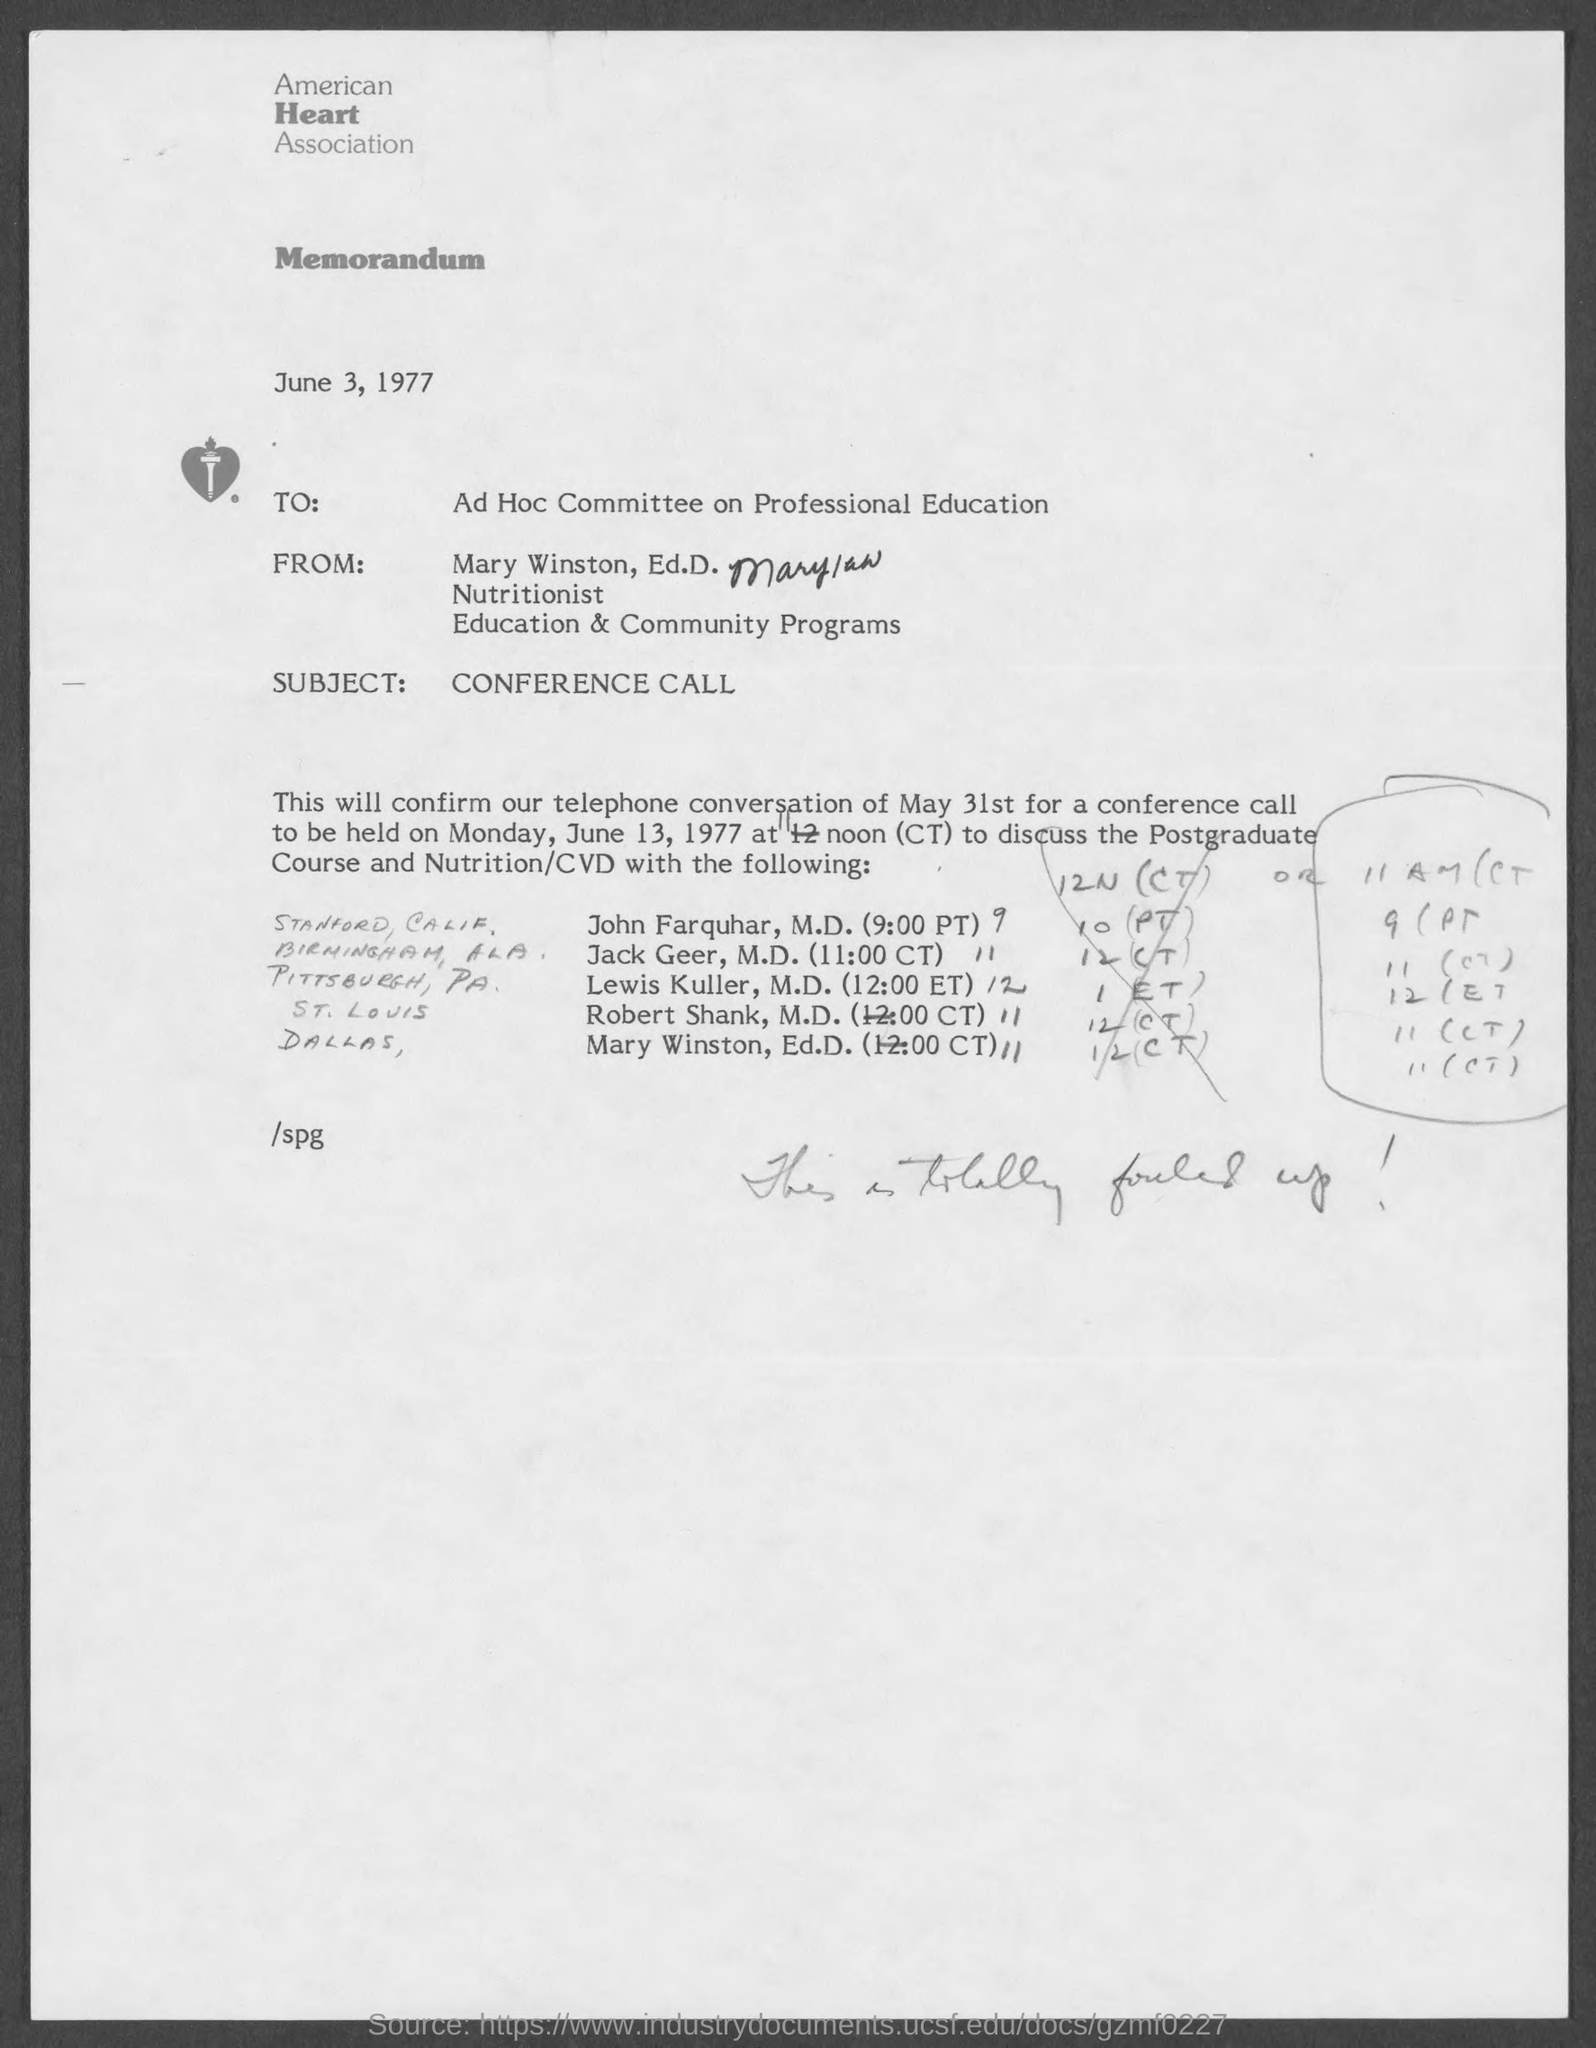Which association is mentioned?
Your response must be concise. American heart association. What type of documentation is this?
Give a very brief answer. Memorandum. When is the document dated?
Your answer should be very brief. June 3, 1977. To whom is the memorandum addressed?
Ensure brevity in your answer.  Ad Hoc Committee on Professional Education. What is Mary Winston, Ed.D.'s title?
Provide a short and direct response. Nutritionist. What is the subject?
Keep it short and to the point. Conference call. 